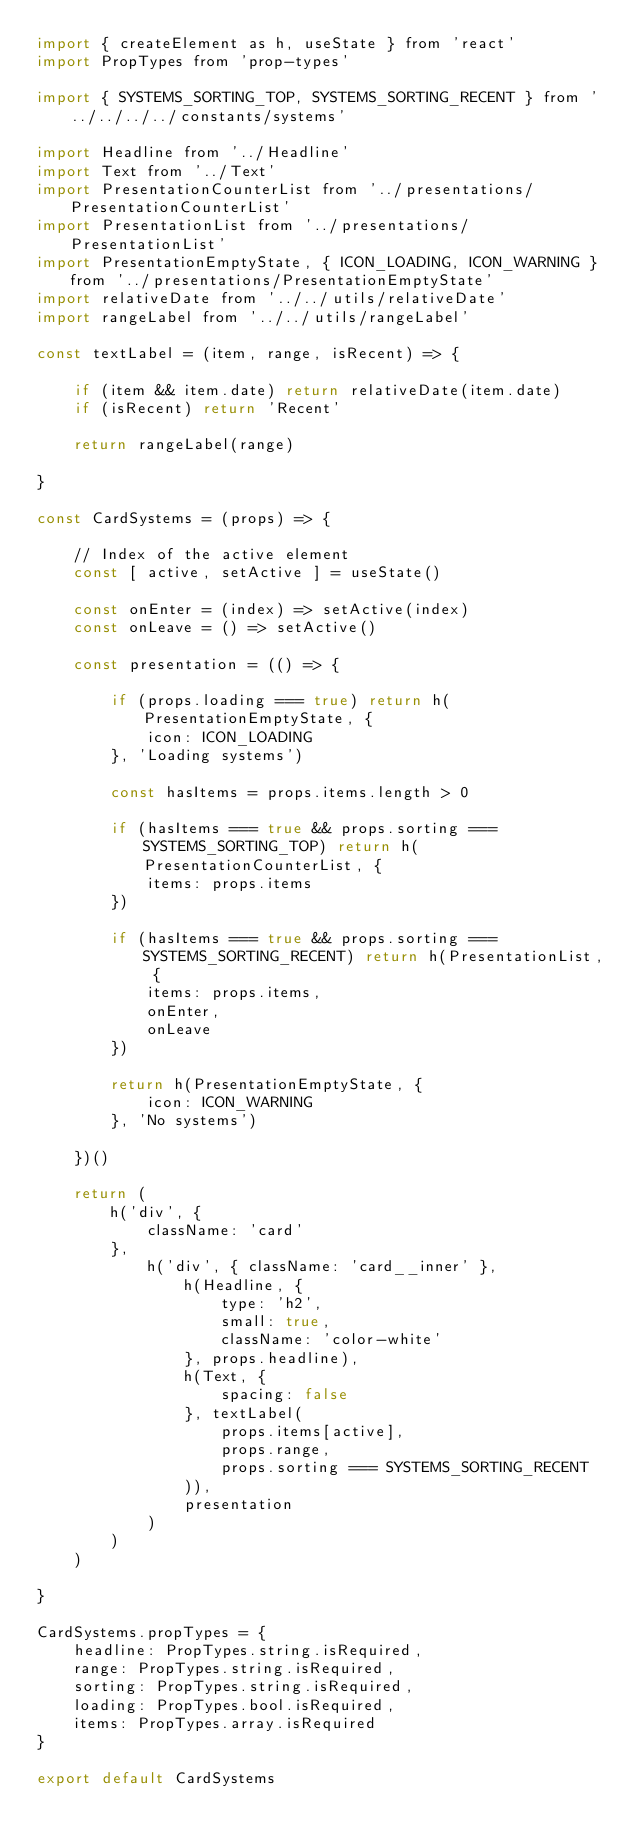<code> <loc_0><loc_0><loc_500><loc_500><_JavaScript_>import { createElement as h, useState } from 'react'
import PropTypes from 'prop-types'

import { SYSTEMS_SORTING_TOP, SYSTEMS_SORTING_RECENT } from '../../../../constants/systems'

import Headline from '../Headline'
import Text from '../Text'
import PresentationCounterList from '../presentations/PresentationCounterList'
import PresentationList from '../presentations/PresentationList'
import PresentationEmptyState, { ICON_LOADING, ICON_WARNING } from '../presentations/PresentationEmptyState'
import relativeDate from '../../utils/relativeDate'
import rangeLabel from '../../utils/rangeLabel'

const textLabel = (item, range, isRecent) => {

	if (item && item.date) return relativeDate(item.date)
	if (isRecent) return 'Recent'

	return rangeLabel(range)

}

const CardSystems = (props) => {

	// Index of the active element
	const [ active, setActive ] = useState()

	const onEnter = (index) => setActive(index)
	const onLeave = () => setActive()

	const presentation = (() => {

		if (props.loading === true) return h(PresentationEmptyState, {
			icon: ICON_LOADING
		}, 'Loading systems')

		const hasItems = props.items.length > 0

		if (hasItems === true && props.sorting === SYSTEMS_SORTING_TOP) return h(PresentationCounterList, {
			items: props.items
		})

		if (hasItems === true && props.sorting === SYSTEMS_SORTING_RECENT) return h(PresentationList, {
			items: props.items,
			onEnter,
			onLeave
		})

		return h(PresentationEmptyState, {
			icon: ICON_WARNING
		}, 'No systems')

	})()

	return (
		h('div', {
			className: 'card'
		},
			h('div', { className: 'card__inner' },
				h(Headline, {
					type: 'h2',
					small: true,
					className: 'color-white'
				}, props.headline),
				h(Text, {
					spacing: false
				}, textLabel(
					props.items[active],
					props.range,
					props.sorting === SYSTEMS_SORTING_RECENT
				)),
				presentation
			)
		)
	)

}

CardSystems.propTypes = {
	headline: PropTypes.string.isRequired,
	range: PropTypes.string.isRequired,
	sorting: PropTypes.string.isRequired,
	loading: PropTypes.bool.isRequired,
	items: PropTypes.array.isRequired
}

export default CardSystems</code> 